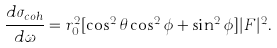<formula> <loc_0><loc_0><loc_500><loc_500>\frac { d \sigma _ { c o h } } { d \omega } = r _ { 0 } ^ { 2 } [ \cos ^ { 2 } \theta \cos ^ { 2 } \phi + \sin ^ { 2 } \phi ] | F | ^ { 2 } .</formula> 